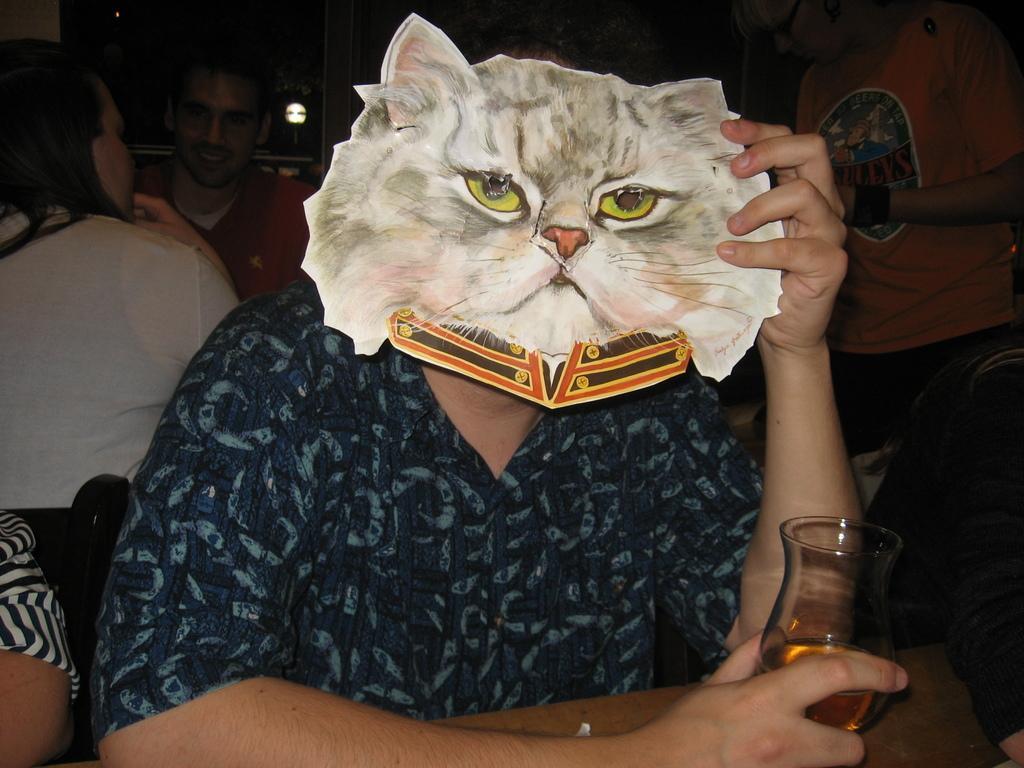Can you describe this image briefly? In this image there is a person sitting and holding a glass of drink and in the other hand, there is a mask of a cat placed in front of the head, beside this person there is another person, behind them there two people sitting with a smile and one is standing the background is dark. 